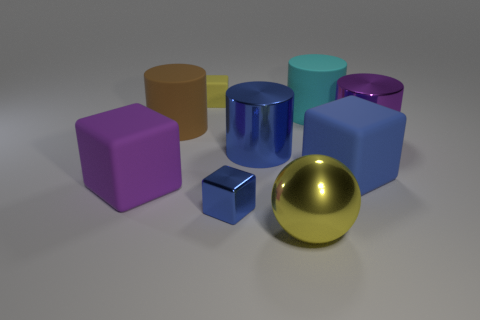Subtract all brown cylinders. How many cylinders are left? 3 Subtract all yellow cylinders. Subtract all gray cubes. How many cylinders are left? 4 Add 1 big purple matte cubes. How many objects exist? 10 Subtract all cubes. How many objects are left? 5 Add 4 cyan cylinders. How many cyan cylinders are left? 5 Add 6 metallic cubes. How many metallic cubes exist? 7 Subtract 0 green cylinders. How many objects are left? 9 Subtract all big purple matte blocks. Subtract all shiny cylinders. How many objects are left? 6 